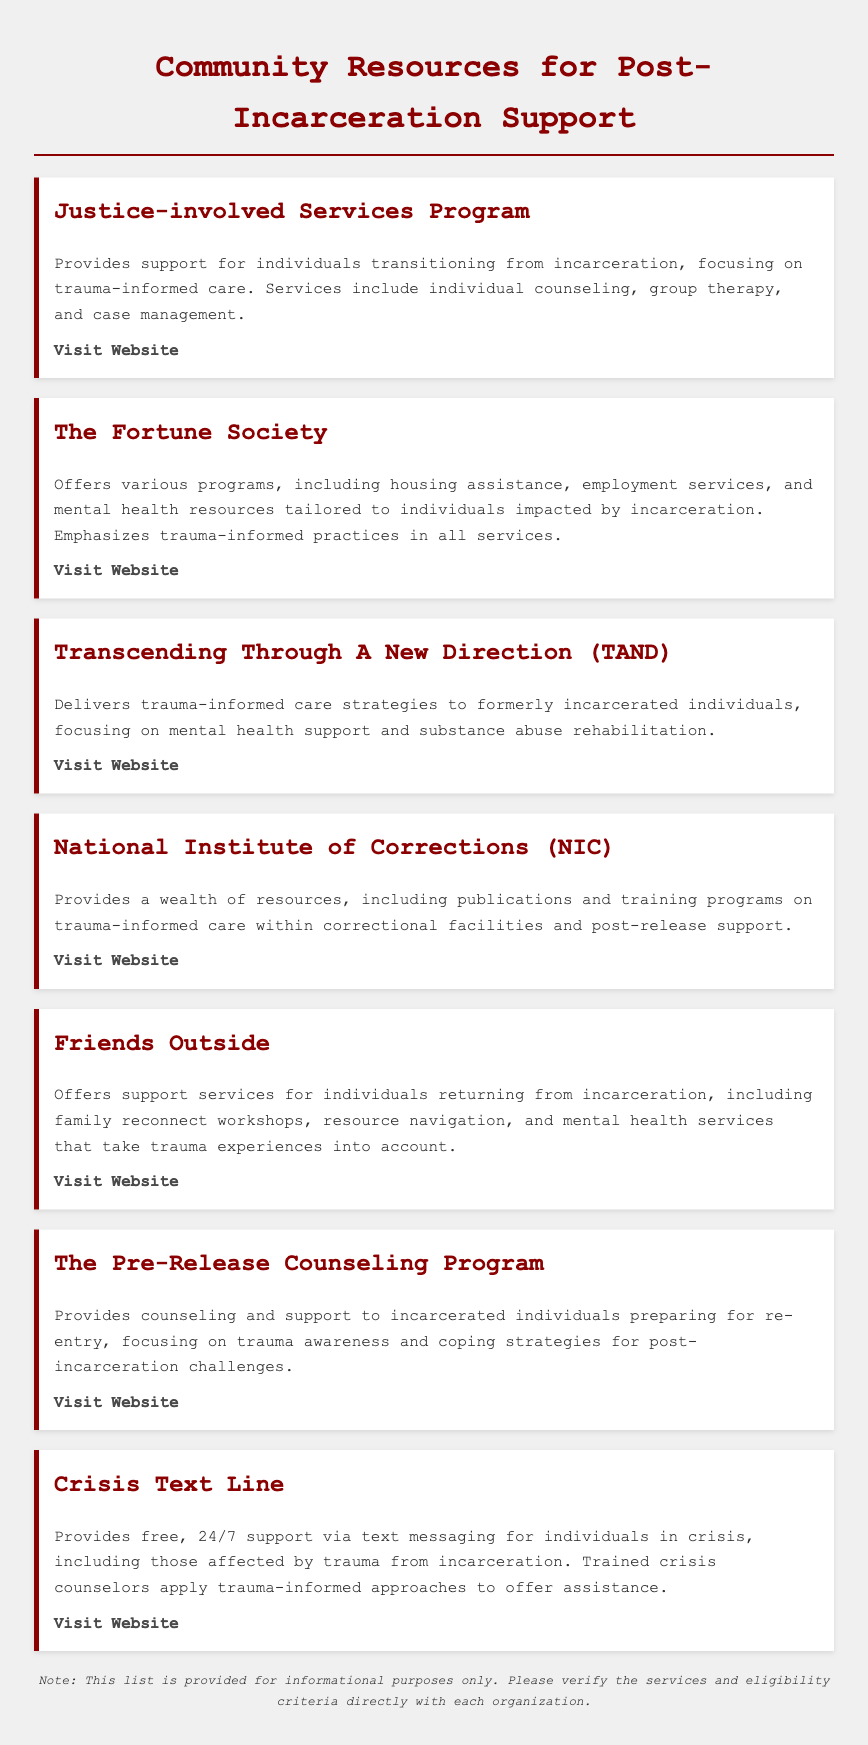What is the name of the program focused on trauma-informed care? The document lists multiple resources, and one of the highlighted programs specifically mentioned for trauma-informed care is the "Justice-involved Services Program."
Answer: Justice-involved Services Program How many resources are listed in the document? There are seven resources provided in the document for supporting clients transitioning from incarceration.
Answer: 7 What type of support does The Fortune Society offer? The Fortune Society provides various programs, including housing assistance, employment services, and mental health resources.
Answer: Housing assistance, employment services, and mental health resources Which resource focuses specifically on crisis support via texting? The document mentions the "Crisis Text Line" as providing free support via text messaging for individuals in crisis.
Answer: Crisis Text Line What is a key strategy used by Transcending Through A New Direction? The organization specifically delivers trauma-informed care strategies focused on mental health support and substance abuse rehabilitation.
Answer: Trauma-informed care strategies What service does Friends Outside provide related to family? Friends Outside offers family reconnect workshops as part of their support services for individuals returning from incarceration.
Answer: Family reconnect workshops What is the webpage for the National Institute of Corrections? The document provides a link for the National Institute of Corrections, which can be found at "https://nicic.gov".
Answer: https://nicic.gov Which program prepares incarcerated individuals for re-entry? The Pre-Release Counseling Program is designed to provide counseling and support to incarcerated individuals preparing for re-entry.
Answer: The Pre-Release Counseling Program 